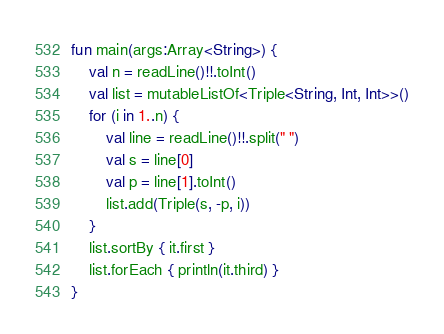<code> <loc_0><loc_0><loc_500><loc_500><_Kotlin_>fun main(args:Array<String>) {
    val n = readLine()!!.toInt()
    val list = mutableListOf<Triple<String, Int, Int>>()
    for (i in 1..n) {
        val line = readLine()!!.split(" ")
        val s = line[0]
        val p = line[1].toInt()
        list.add(Triple(s, -p, i))
    }
    list.sortBy { it.first }
    list.forEach { println(it.third) }
}</code> 